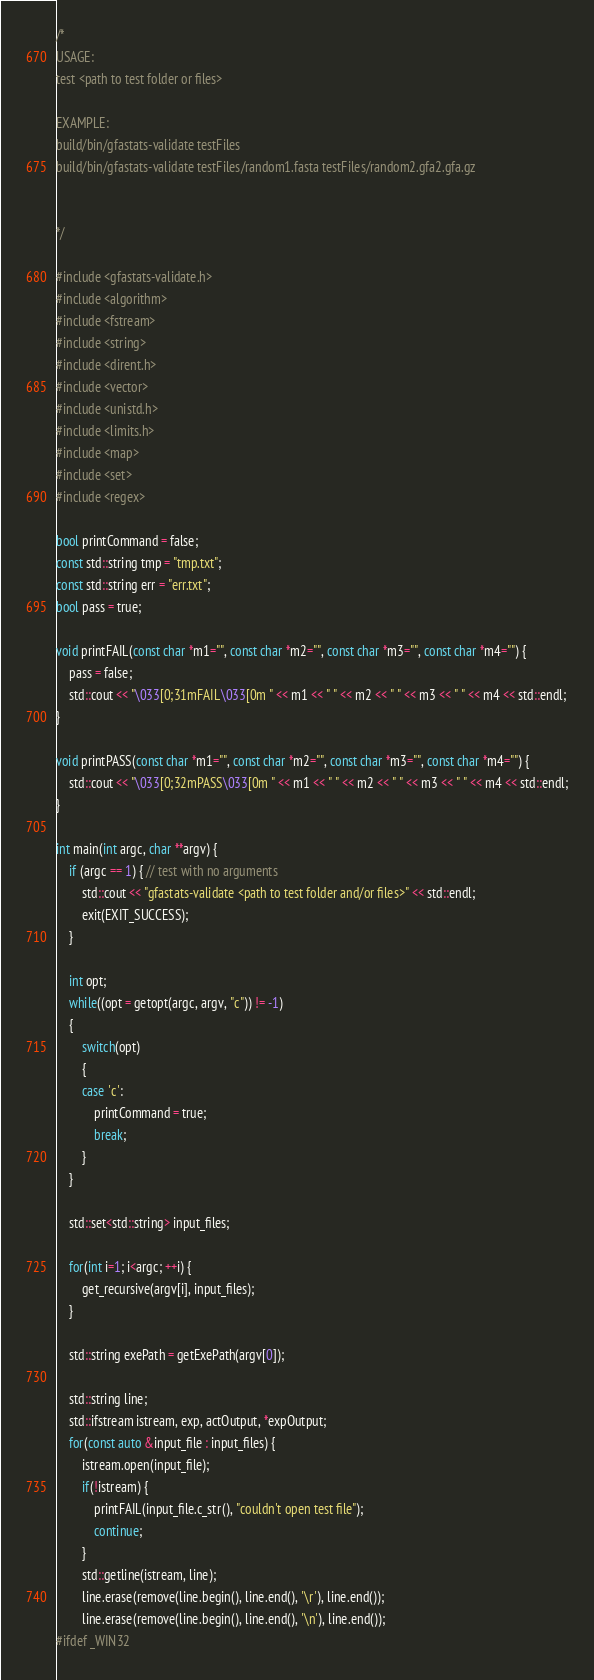<code> <loc_0><loc_0><loc_500><loc_500><_C++_>/*
USAGE:
test <path to test folder or files>

EXAMPLE:
build/bin/gfastats-validate testFiles
build/bin/gfastats-validate testFiles/random1.fasta testFiles/random2.gfa2.gfa.gz


*/

#include <gfastats-validate.h>
#include <algorithm>
#include <fstream>
#include <string>
#include <dirent.h>
#include <vector>
#include <unistd.h>
#include <limits.h>
#include <map>
#include <set>
#include <regex>

bool printCommand = false;
const std::string tmp = "tmp.txt";
const std::string err = "err.txt";
bool pass = true;

void printFAIL(const char *m1="", const char *m2="", const char *m3="", const char *m4="") {
    pass = false;
    std::cout << "\033[0;31mFAIL\033[0m " << m1 << " " << m2 << " " << m3 << " " << m4 << std::endl;
}

void printPASS(const char *m1="", const char *m2="", const char *m3="", const char *m4="") {
    std::cout << "\033[0;32mPASS\033[0m " << m1 << " " << m2 << " " << m3 << " " << m4 << std::endl;
}

int main(int argc, char **argv) {
    if (argc == 1) { // test with no arguments
        std::cout << "gfastats-validate <path to test folder and/or files>" << std::endl;
        exit(EXIT_SUCCESS);
    }

    int opt;
    while((opt = getopt(argc, argv, "c")) != -1) 
    {
        switch(opt) 
        {
        case 'c':
            printCommand = true;
            break;
        }
    }

    std::set<std::string> input_files;

    for(int i=1; i<argc; ++i) {
        get_recursive(argv[i], input_files);
    }

    std::string exePath = getExePath(argv[0]);

    std::string line;
    std::ifstream istream, exp, actOutput, *expOutput;
    for(const auto &input_file : input_files) {
        istream.open(input_file);
        if(!istream) {
            printFAIL(input_file.c_str(), "couldn't open test file");
            continue;
        }
        std::getline(istream, line);
        line.erase(remove(line.begin(), line.end(), '\r'), line.end());
        line.erase(remove(line.begin(), line.end(), '\n'), line.end());
#ifdef _WIN32</code> 